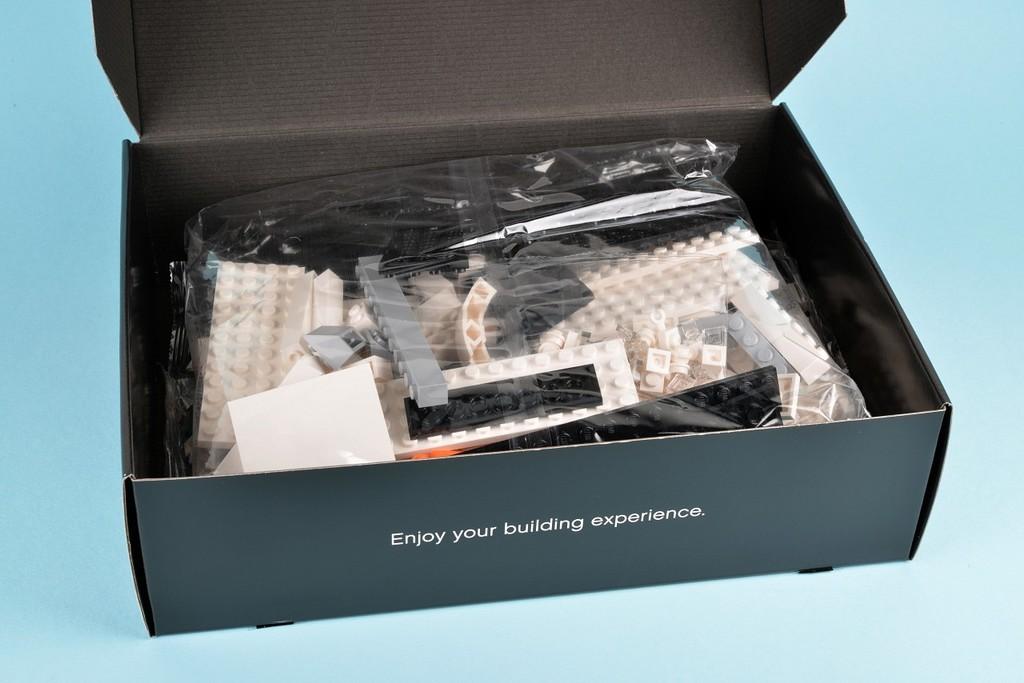Does the box mention to enjoy your experience?
Offer a terse response. Yes. 